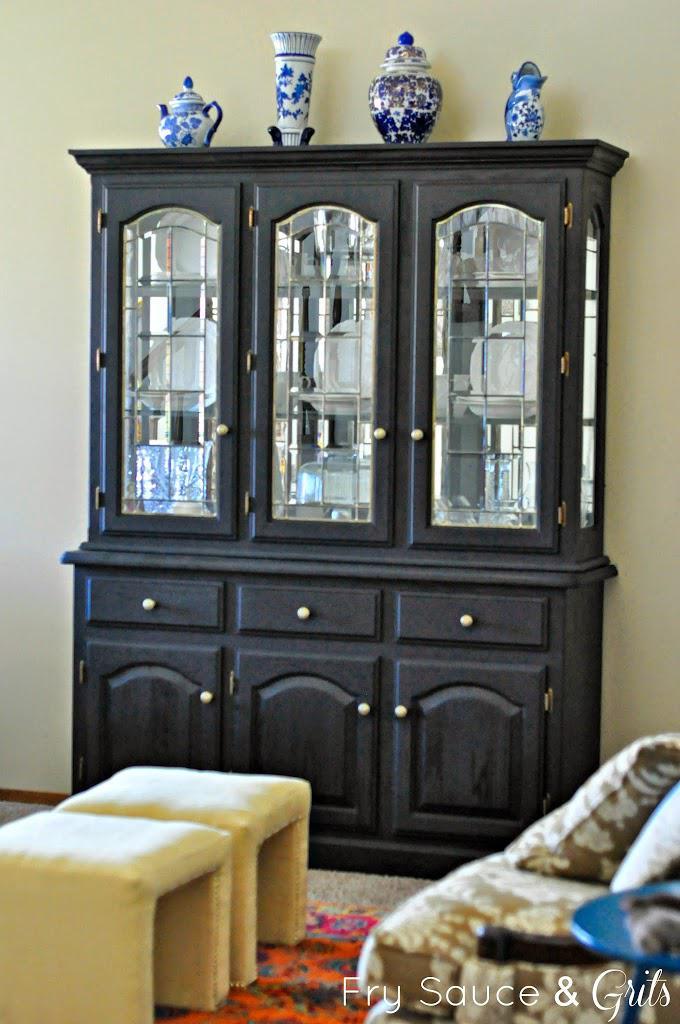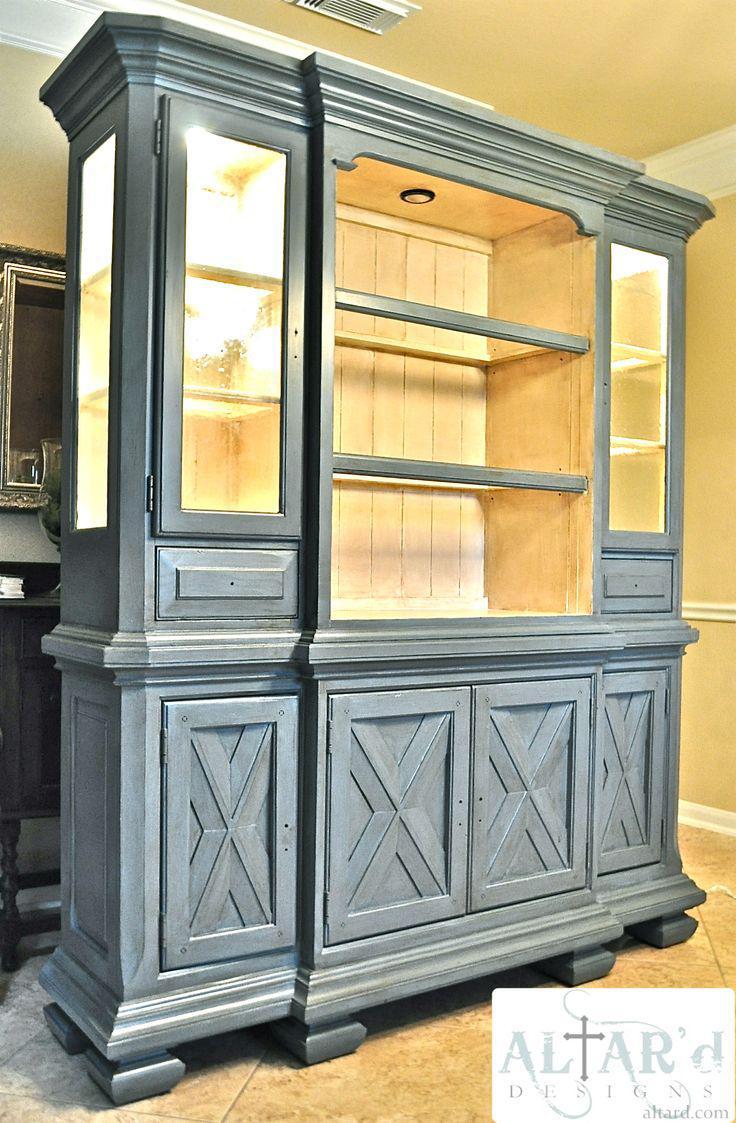The first image is the image on the left, the second image is the image on the right. For the images shown, is this caption "There is at least one item on top of the cabinet in the image on the left." true? Answer yes or no. Yes. 